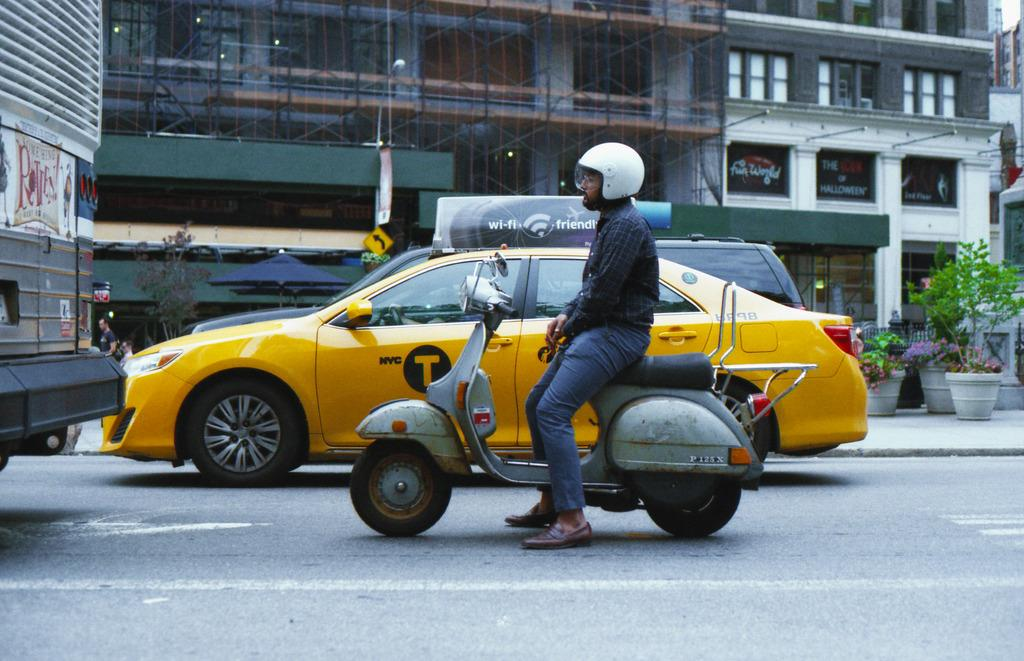<image>
Give a short and clear explanation of the subsequent image. A yellow NYC taxi waits in traffic along side a man on a scooter. 